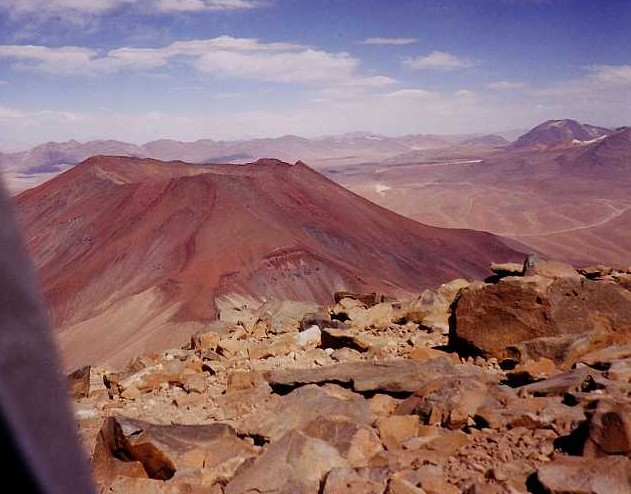How old might this mountain be, and can we tell from the image? Estimating the age of the mountain from the image alone is challenging without specific geological data. However, if it is a shield volcano, as suggested by its shape and color, it could be millions of years old since these formations grow gradually over long periods through repeated lava flows. In contrast, sedimentary formations might suggest a different timeline, heavily influenced by erosion rates and the deposition of materials over epochs. 